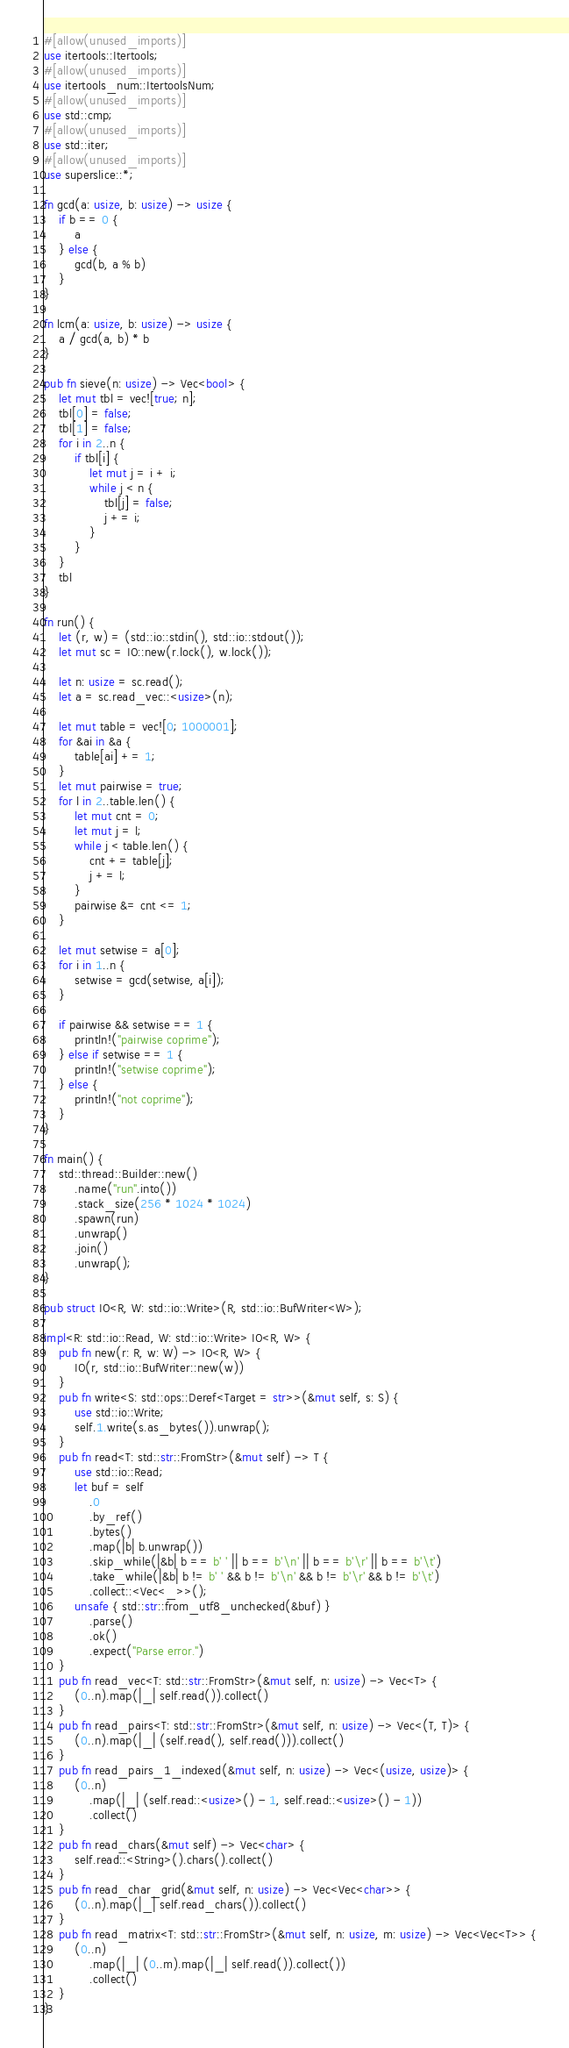Convert code to text. <code><loc_0><loc_0><loc_500><loc_500><_Rust_>#[allow(unused_imports)]
use itertools::Itertools;
#[allow(unused_imports)]
use itertools_num::ItertoolsNum;
#[allow(unused_imports)]
use std::cmp;
#[allow(unused_imports)]
use std::iter;
#[allow(unused_imports)]
use superslice::*;

fn gcd(a: usize, b: usize) -> usize {
    if b == 0 {
        a
    } else {
        gcd(b, a % b)
    }
}

fn lcm(a: usize, b: usize) -> usize {
    a / gcd(a, b) * b
}

pub fn sieve(n: usize) -> Vec<bool> {
    let mut tbl = vec![true; n];
    tbl[0] = false;
    tbl[1] = false;
    for i in 2..n {
        if tbl[i] {
            let mut j = i + i;
            while j < n {
                tbl[j] = false;
                j += i;
            }
        }
    }
    tbl
}

fn run() {
    let (r, w) = (std::io::stdin(), std::io::stdout());
    let mut sc = IO::new(r.lock(), w.lock());

    let n: usize = sc.read();
    let a = sc.read_vec::<usize>(n);

    let mut table = vec![0; 1000001];
    for &ai in &a {
        table[ai] += 1;
    }
    let mut pairwise = true;
    for l in 2..table.len() {
        let mut cnt = 0;
        let mut j = l;
        while j < table.len() {
            cnt += table[j];
            j += l;
        }
        pairwise &= cnt <= 1;
    }

    let mut setwise = a[0];
    for i in 1..n {
        setwise = gcd(setwise, a[i]);
    }

    if pairwise && setwise == 1 {
        println!("pairwise coprime");
    } else if setwise == 1 {
        println!("setwise coprime");
    } else {
        println!("not coprime");
    }
}

fn main() {
    std::thread::Builder::new()
        .name("run".into())
        .stack_size(256 * 1024 * 1024)
        .spawn(run)
        .unwrap()
        .join()
        .unwrap();
}

pub struct IO<R, W: std::io::Write>(R, std::io::BufWriter<W>);

impl<R: std::io::Read, W: std::io::Write> IO<R, W> {
    pub fn new(r: R, w: W) -> IO<R, W> {
        IO(r, std::io::BufWriter::new(w))
    }
    pub fn write<S: std::ops::Deref<Target = str>>(&mut self, s: S) {
        use std::io::Write;
        self.1.write(s.as_bytes()).unwrap();
    }
    pub fn read<T: std::str::FromStr>(&mut self) -> T {
        use std::io::Read;
        let buf = self
            .0
            .by_ref()
            .bytes()
            .map(|b| b.unwrap())
            .skip_while(|&b| b == b' ' || b == b'\n' || b == b'\r' || b == b'\t')
            .take_while(|&b| b != b' ' && b != b'\n' && b != b'\r' && b != b'\t')
            .collect::<Vec<_>>();
        unsafe { std::str::from_utf8_unchecked(&buf) }
            .parse()
            .ok()
            .expect("Parse error.")
    }
    pub fn read_vec<T: std::str::FromStr>(&mut self, n: usize) -> Vec<T> {
        (0..n).map(|_| self.read()).collect()
    }
    pub fn read_pairs<T: std::str::FromStr>(&mut self, n: usize) -> Vec<(T, T)> {
        (0..n).map(|_| (self.read(), self.read())).collect()
    }
    pub fn read_pairs_1_indexed(&mut self, n: usize) -> Vec<(usize, usize)> {
        (0..n)
            .map(|_| (self.read::<usize>() - 1, self.read::<usize>() - 1))
            .collect()
    }
    pub fn read_chars(&mut self) -> Vec<char> {
        self.read::<String>().chars().collect()
    }
    pub fn read_char_grid(&mut self, n: usize) -> Vec<Vec<char>> {
        (0..n).map(|_| self.read_chars()).collect()
    }
    pub fn read_matrix<T: std::str::FromStr>(&mut self, n: usize, m: usize) -> Vec<Vec<T>> {
        (0..n)
            .map(|_| (0..m).map(|_| self.read()).collect())
            .collect()
    }
}
</code> 